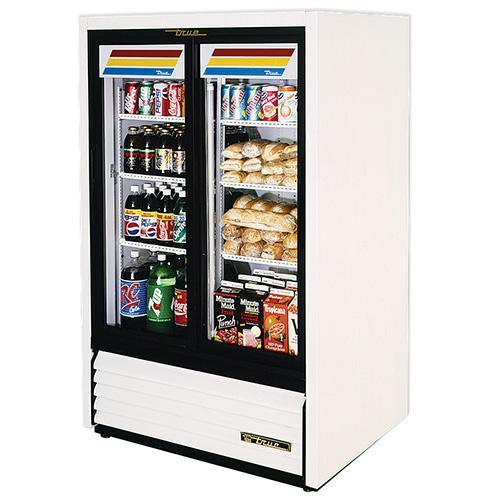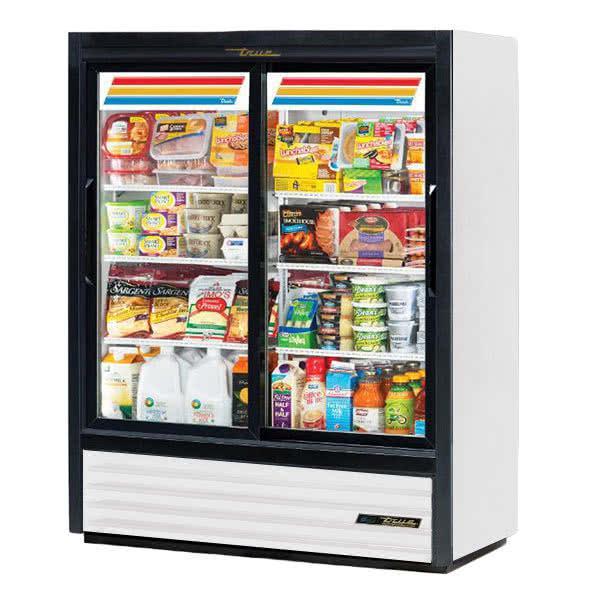The first image is the image on the left, the second image is the image on the right. Assess this claim about the two images: "Two vending machines are white with black trim and two large glass doors, but one has one set of three wide color stripes at the top, while the other has two sets of narrower color stripes.". Correct or not? Answer yes or no. No. The first image is the image on the left, the second image is the image on the right. For the images shown, is this caption "One image features a vending machine with an undivided band of three colors across the top." true? Answer yes or no. No. 